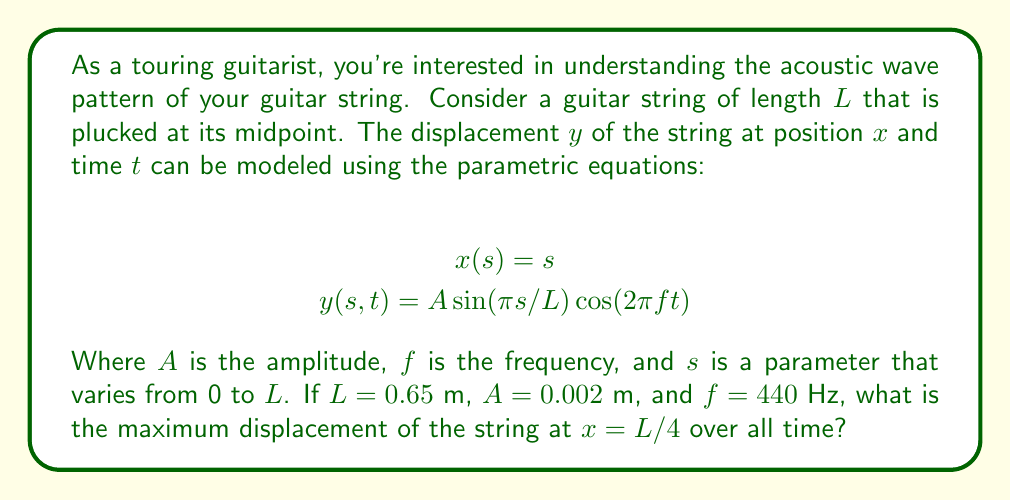Can you answer this question? To solve this problem, we'll follow these steps:

1) First, we need to understand what the equations represent:
   - $x(s) = s$ means that the $x$-coordinate is simply equal to $s$.
   - $y(s,t)$ gives the displacement of the string at position $s$ and time $t$.

2) We're asked about the point $x = L/4$. In terms of our parameter $s$, this means:
   $s = L/4 = 0.65/4 = 0.1625$ m

3) Now, we substitute this into the equation for $y$:
   $$y(0.1625,t) = A \sin(\pi (0.1625)/L) \cos(2\pi ft)$$

4) Simplify the sine term:
   $$\sin(\pi (0.1625)/0.65) = \sin(\pi/4) = \frac{\sqrt{2}}{2}$$

5) Our equation is now:
   $$y(0.1625,t) = 0.002 \cdot \frac{\sqrt{2}}{2} \cdot \cos(2\pi \cdot 440t)$$

6) The cosine term oscillates between -1 and 1. The maximum displacement will occur when this term is at its maximum absolute value, which is 1.

7) Therefore, the maximum displacement is:
   $$y_{max} = 0.002 \cdot \frac{\sqrt{2}}{2} = 0.002 \cdot \frac{\sqrt{2}}{2} = 0.001\sqrt{2}$$ meters
Answer: The maximum displacement of the string at $x = L/4$ over all time is $0.001\sqrt{2}$ meters, or approximately 0.001414 meters. 